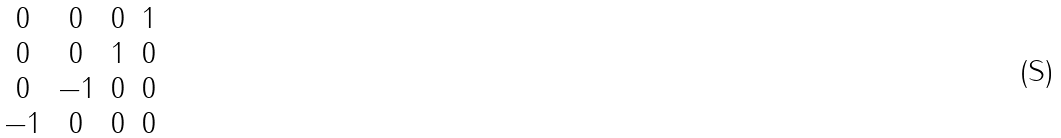Convert formula to latex. <formula><loc_0><loc_0><loc_500><loc_500>\begin{matrix} 0 & 0 & 0 & 1 \\ 0 & 0 & 1 & 0 \\ 0 & - 1 & 0 & 0 \\ - 1 & 0 & 0 & 0 \end{matrix}</formula> 